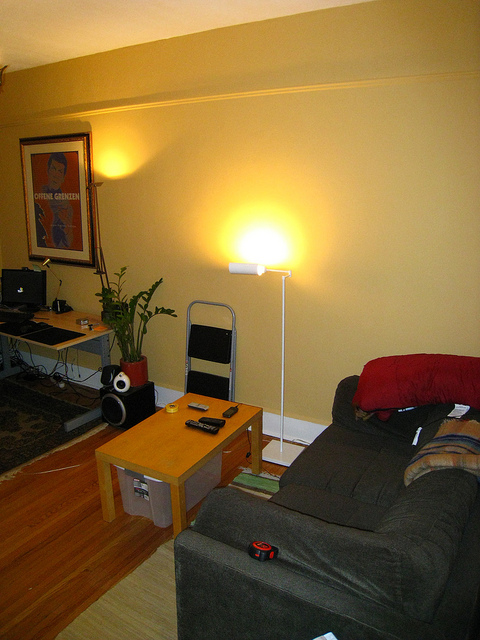<image>Where is the bed? The bed is not shown in the image. However, it is typically located in the bedroom. Where is the bed? I don't know where the bed is. It is not shown in the image. 